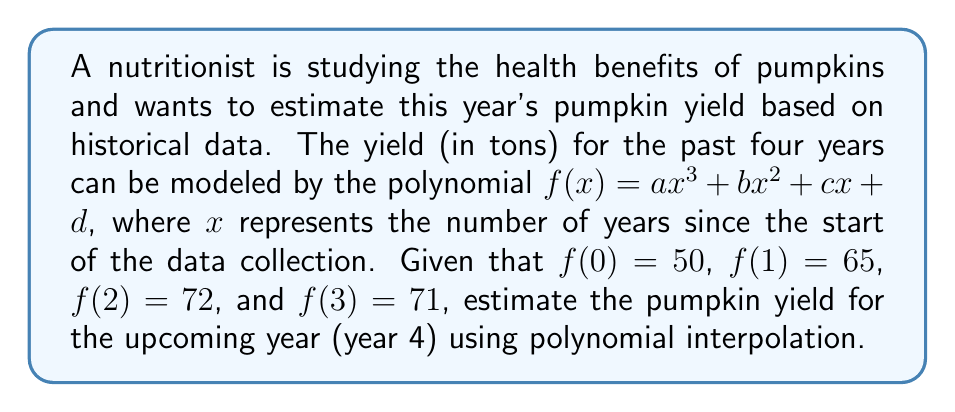Solve this math problem. To solve this problem, we'll follow these steps:

1) We have four data points, so we can determine a unique cubic polynomial that passes through all of them.

2) We know that $f(x) = ax^3 + bx^2 + cx + d$. Let's use the given data to set up a system of equations:

   $f(0) = d = 50$
   $f(1) = a + b + c + d = 65$
   $f(2) = 8a + 4b + 2c + d = 72$
   $f(3) = 27a + 9b + 3c + d = 71$

3) From the first equation, we know $d = 50$. Substituting this into the other equations:

   $a + b + c = 15$
   $8a + 4b + 2c = 22$
   $27a + 9b + 3c = 21$

4) Subtracting the first equation from the second:
   $7a + 3b + c = 7$

5) Subtracting the first equation from the third:
   $26a + 8b + 2c = 6$

6) Now we have a system of three equations with three unknowns:
   $a + b + c = 15$
   $7a + 3b + c = 7$
   $26a + 8b + 2c = 6$

7) Solving this system (which can be done using matrix methods or elimination), we get:
   $a = -2$, $b = 9$, $c = 8$

8) Therefore, our polynomial is:
   $f(x) = -2x^3 + 9x^2 + 8x + 50$

9) To estimate the yield for year 4, we calculate $f(4)$:

   $f(4) = -2(4^3) + 9(4^2) + 8(4) + 50$
         $= -128 + 144 + 32 + 50$
         $= 98$

Thus, the estimated pumpkin yield for year 4 is 98 tons.
Answer: 98 tons 